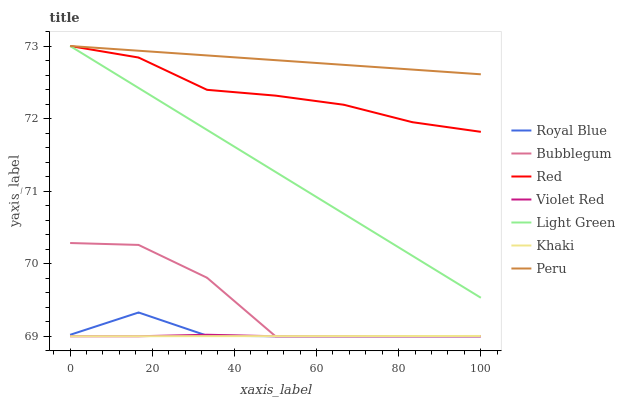Does Khaki have the minimum area under the curve?
Answer yes or no. Yes. Does Peru have the maximum area under the curve?
Answer yes or no. Yes. Does Peru have the minimum area under the curve?
Answer yes or no. No. Does Khaki have the maximum area under the curve?
Answer yes or no. No. Is Light Green the smoothest?
Answer yes or no. Yes. Is Bubblegum the roughest?
Answer yes or no. Yes. Is Khaki the smoothest?
Answer yes or no. No. Is Khaki the roughest?
Answer yes or no. No. Does Violet Red have the lowest value?
Answer yes or no. Yes. Does Peru have the lowest value?
Answer yes or no. No. Does Red have the highest value?
Answer yes or no. Yes. Does Khaki have the highest value?
Answer yes or no. No. Is Khaki less than Red?
Answer yes or no. Yes. Is Peru greater than Violet Red?
Answer yes or no. Yes. Does Light Green intersect Red?
Answer yes or no. Yes. Is Light Green less than Red?
Answer yes or no. No. Is Light Green greater than Red?
Answer yes or no. No. Does Khaki intersect Red?
Answer yes or no. No. 